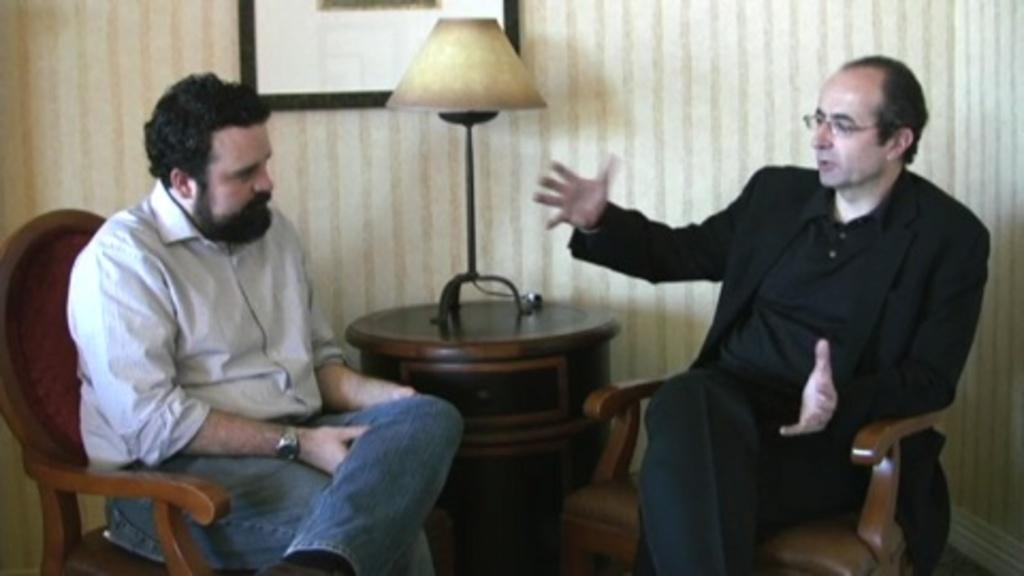How many people are in the image? There are two men in the image. What are the men doing in the image? The men are sitting in chairs and talking to each other. How are the chairs arranged in the image? The chairs are facing each other. What object can be seen on a table in the image? There is a lamp on a table in the image. What is hanging on the wall in the background? There is a photo frame attached to the wall in the background. Can you hear the whistle of the wind in the image? There is no mention of wind or a whistle in the image, so it cannot be heard. 